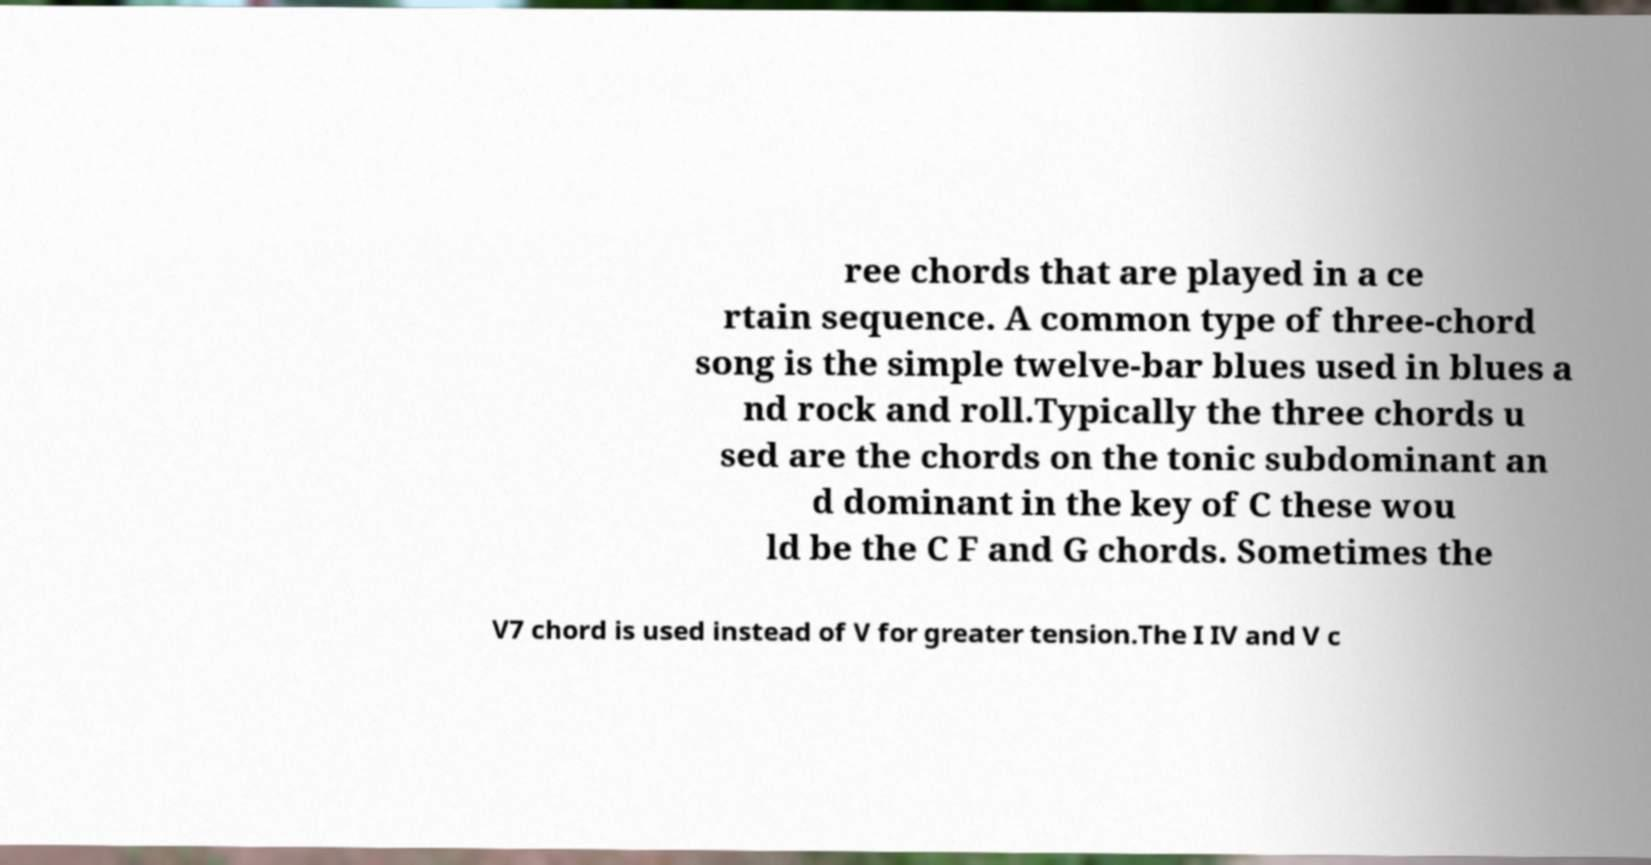Can you read and provide the text displayed in the image?This photo seems to have some interesting text. Can you extract and type it out for me? ree chords that are played in a ce rtain sequence. A common type of three-chord song is the simple twelve-bar blues used in blues a nd rock and roll.Typically the three chords u sed are the chords on the tonic subdominant an d dominant in the key of C these wou ld be the C F and G chords. Sometimes the V7 chord is used instead of V for greater tension.The I IV and V c 